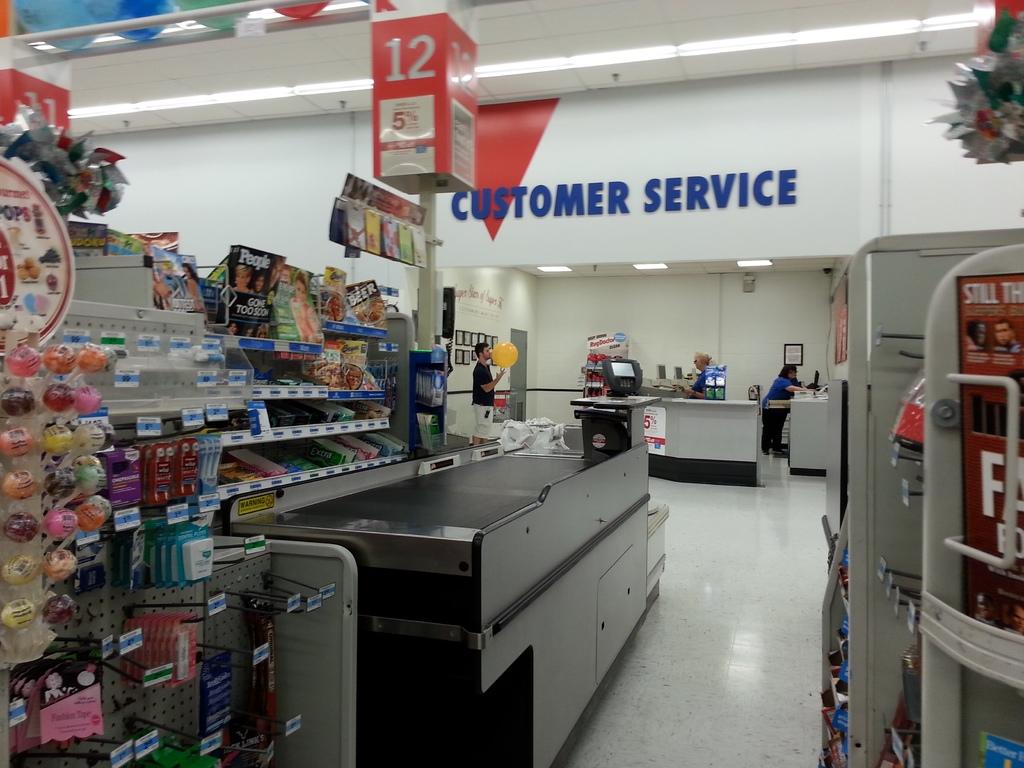What register number is this?
Your answer should be very brief. 12. What department is the man with the yellow ball standing in?
Offer a terse response. Customer service. 